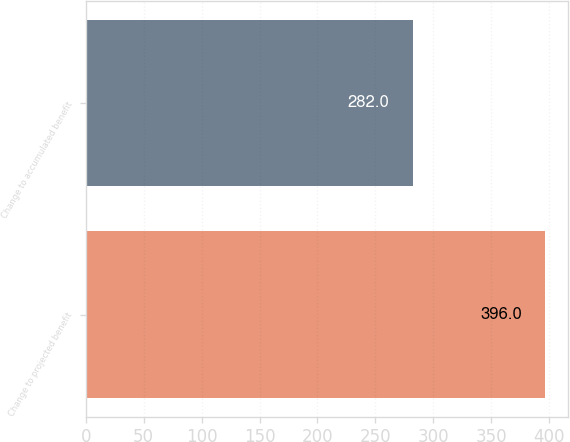Convert chart. <chart><loc_0><loc_0><loc_500><loc_500><bar_chart><fcel>Change to projected benefit<fcel>Change to accumulated benefit<nl><fcel>396<fcel>282<nl></chart> 